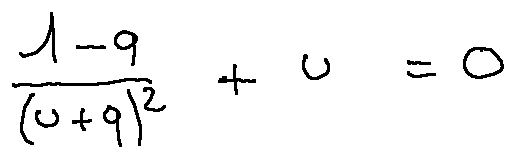Convert formula to latex. <formula><loc_0><loc_0><loc_500><loc_500>\frac { 1 - q } { ( u + q ) ^ { 2 } } + u = 0</formula> 